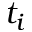<formula> <loc_0><loc_0><loc_500><loc_500>t _ { i }</formula> 